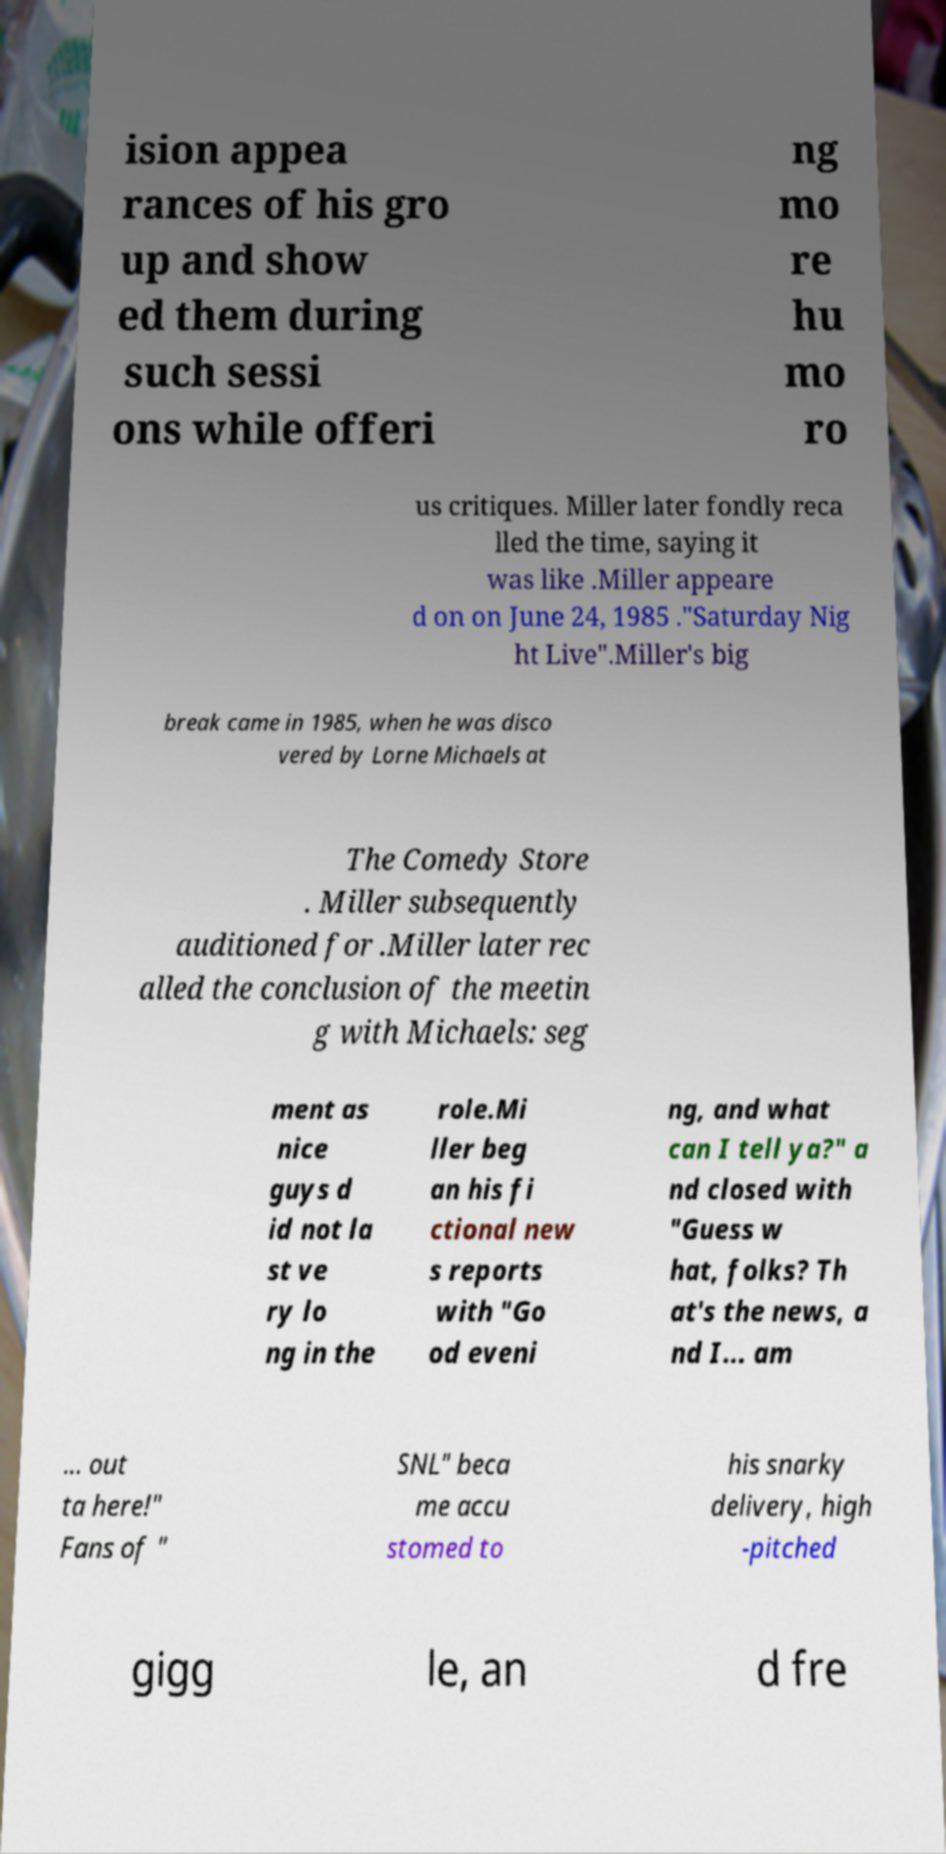Please identify and transcribe the text found in this image. ision appea rances of his gro up and show ed them during such sessi ons while offeri ng mo re hu mo ro us critiques. Miller later fondly reca lled the time, saying it was like .Miller appeare d on on June 24, 1985 ."Saturday Nig ht Live".Miller's big break came in 1985, when he was disco vered by Lorne Michaels at The Comedy Store . Miller subsequently auditioned for .Miller later rec alled the conclusion of the meetin g with Michaels: seg ment as nice guys d id not la st ve ry lo ng in the role.Mi ller beg an his fi ctional new s reports with "Go od eveni ng, and what can I tell ya?" a nd closed with "Guess w hat, folks? Th at's the news, a nd I... am ... out ta here!" Fans of " SNL" beca me accu stomed to his snarky delivery, high -pitched gigg le, an d fre 